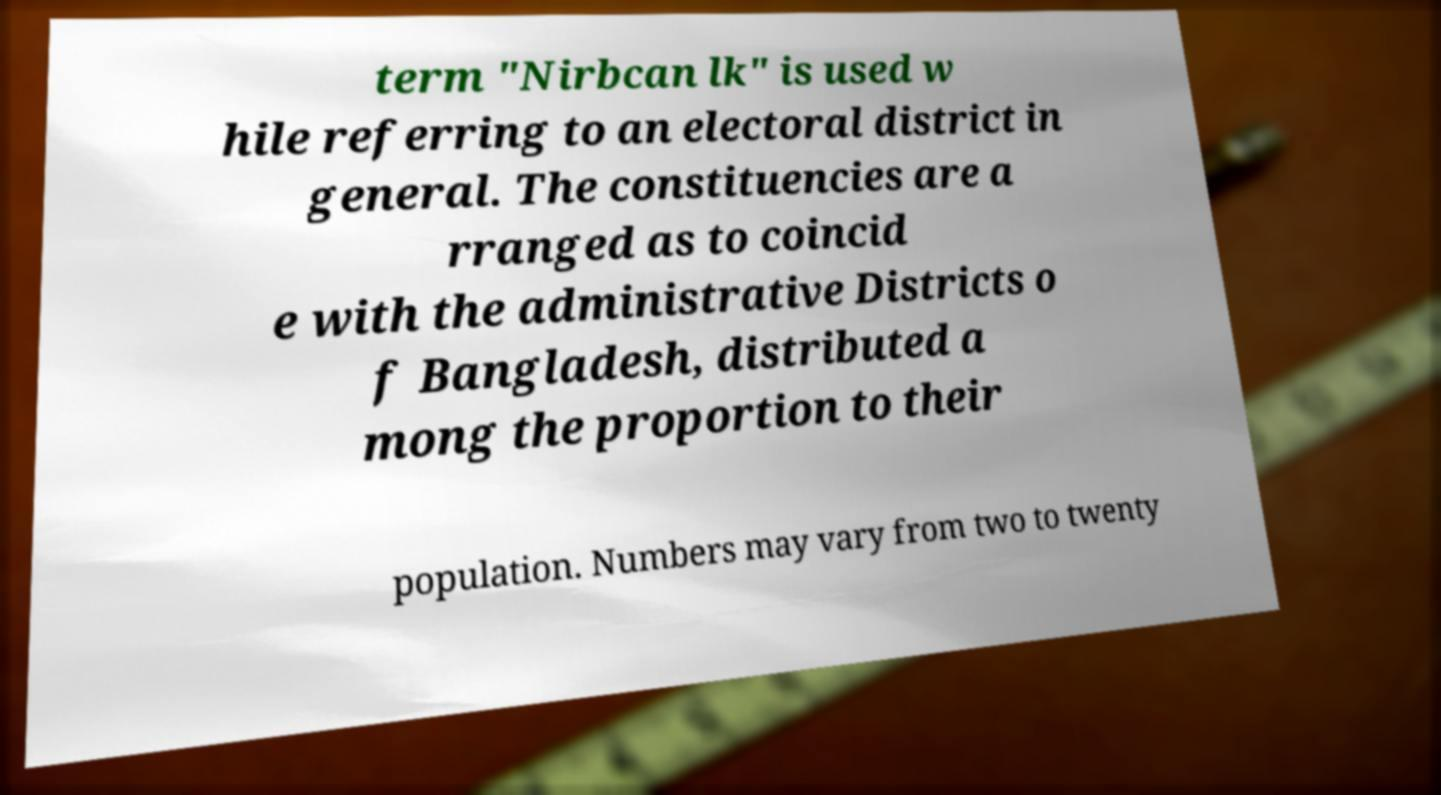There's text embedded in this image that I need extracted. Can you transcribe it verbatim? term "Nirbcan lk" is used w hile referring to an electoral district in general. The constituencies are a rranged as to coincid e with the administrative Districts o f Bangladesh, distributed a mong the proportion to their population. Numbers may vary from two to twenty 